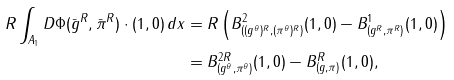Convert formula to latex. <formula><loc_0><loc_0><loc_500><loc_500>R \int _ { A _ { 1 } } D \Phi ( \bar { g } ^ { R } , \bar { \pi } ^ { R } ) \cdot ( 1 , 0 ) \, d x & = R \left ( B ^ { 2 } _ { ( ( g ^ { \theta } ) ^ { R } , ( \pi ^ { \theta } ) ^ { R } ) } ( 1 , 0 ) - B ^ { 1 } _ { ( g ^ { R } , \pi ^ { R } ) } ( 1 , 0 ) \right ) \\ & = B ^ { 2 R } _ { ( g ^ { \theta } , \pi ^ { \theta } ) } ( 1 , 0 ) - B ^ { R } _ { ( g , \pi ) } ( 1 , 0 ) ,</formula> 